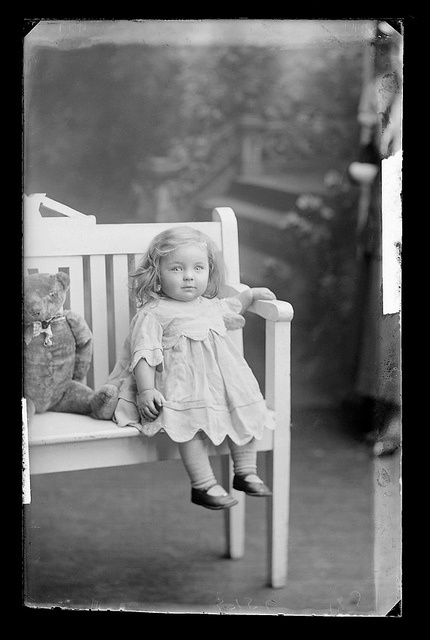Describe the objects in this image and their specific colors. I can see bench in black, lightgray, darkgray, and gray tones, people in black, lightgray, darkgray, and gray tones, and teddy bear in black, darkgray, gray, and lightgray tones in this image. 